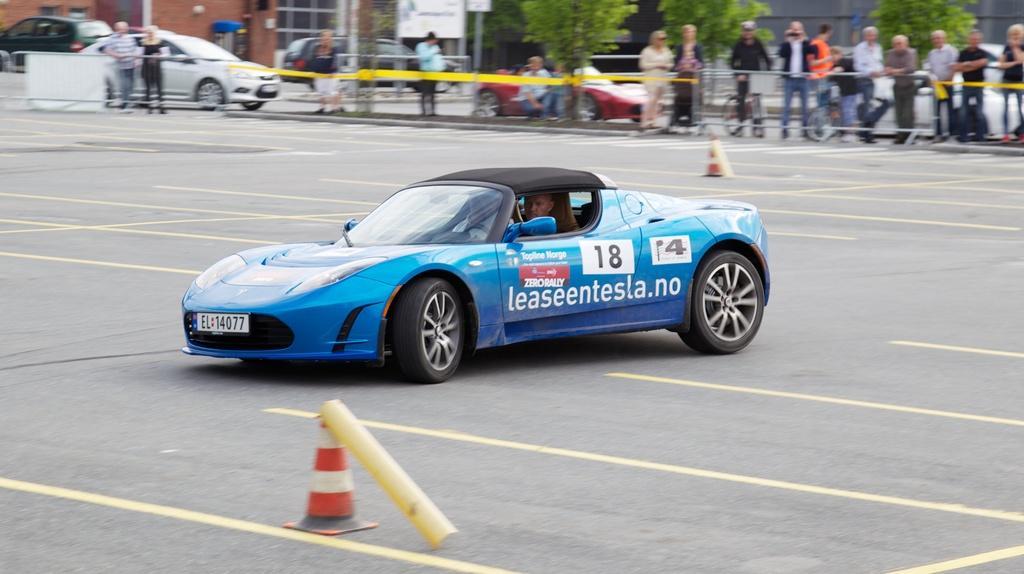Please provide a concise description of this image. In this image in the center there is one car, and in the car there are two persons sitting and at the bottom there is a barricade. And in the background there are group of people standing, and there are some cars, barricades, tape and some cycles, trees, buildings, poles, boards. At the bottom there is road. 